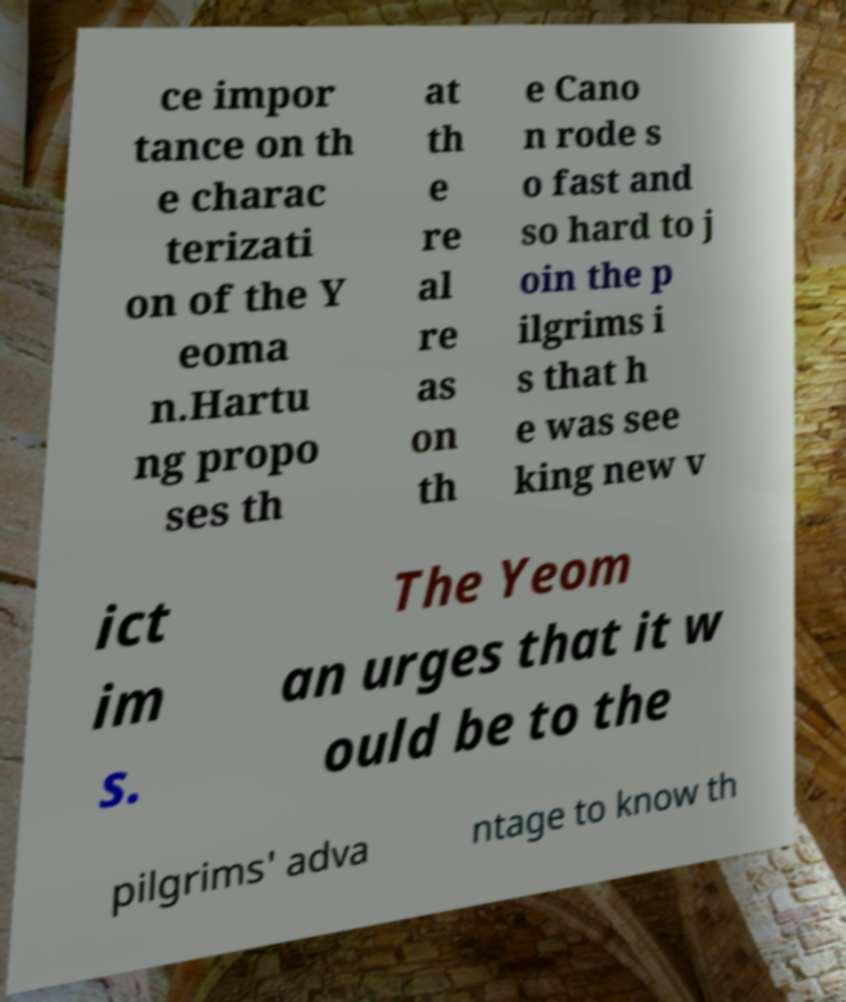Please read and relay the text visible in this image. What does it say? ce impor tance on th e charac terizati on of the Y eoma n.Hartu ng propo ses th at th e re al re as on th e Cano n rode s o fast and so hard to j oin the p ilgrims i s that h e was see king new v ict im s. The Yeom an urges that it w ould be to the pilgrims' adva ntage to know th 